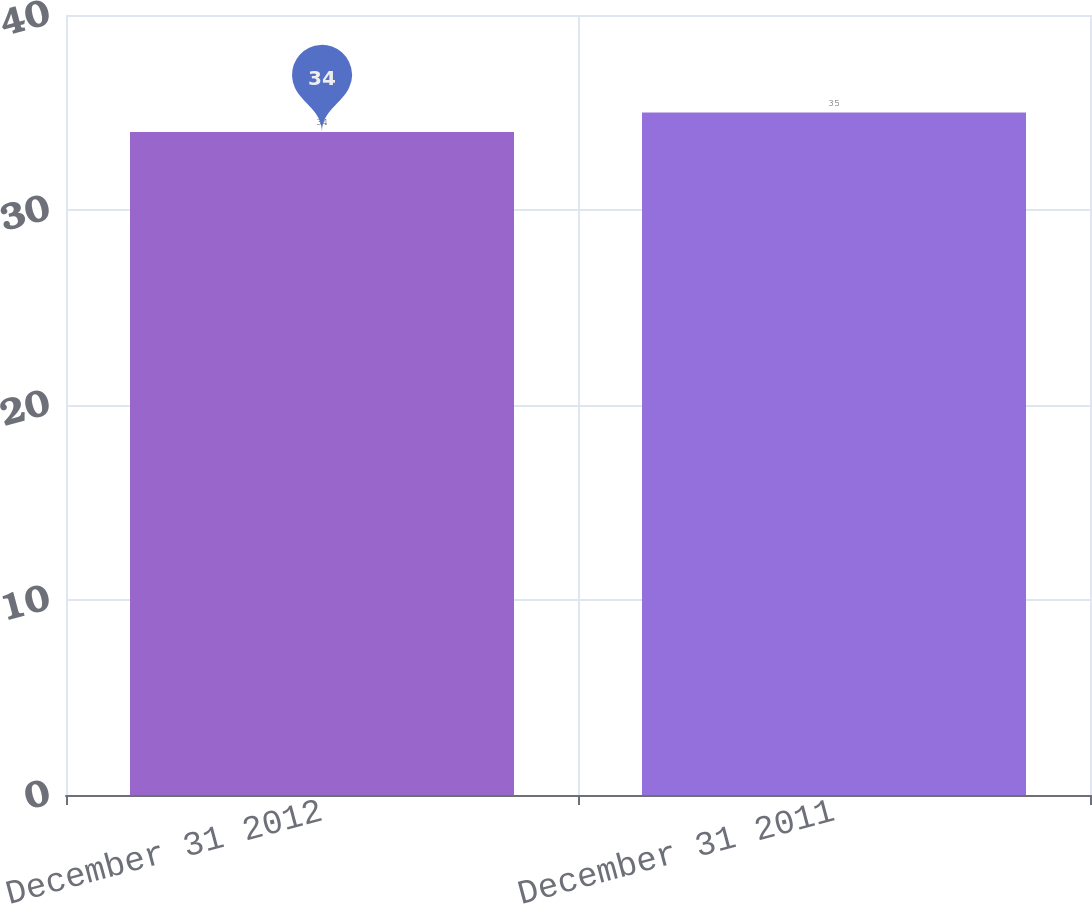Convert chart. <chart><loc_0><loc_0><loc_500><loc_500><bar_chart><fcel>December 31 2012<fcel>December 31 2011<nl><fcel>34<fcel>35<nl></chart> 